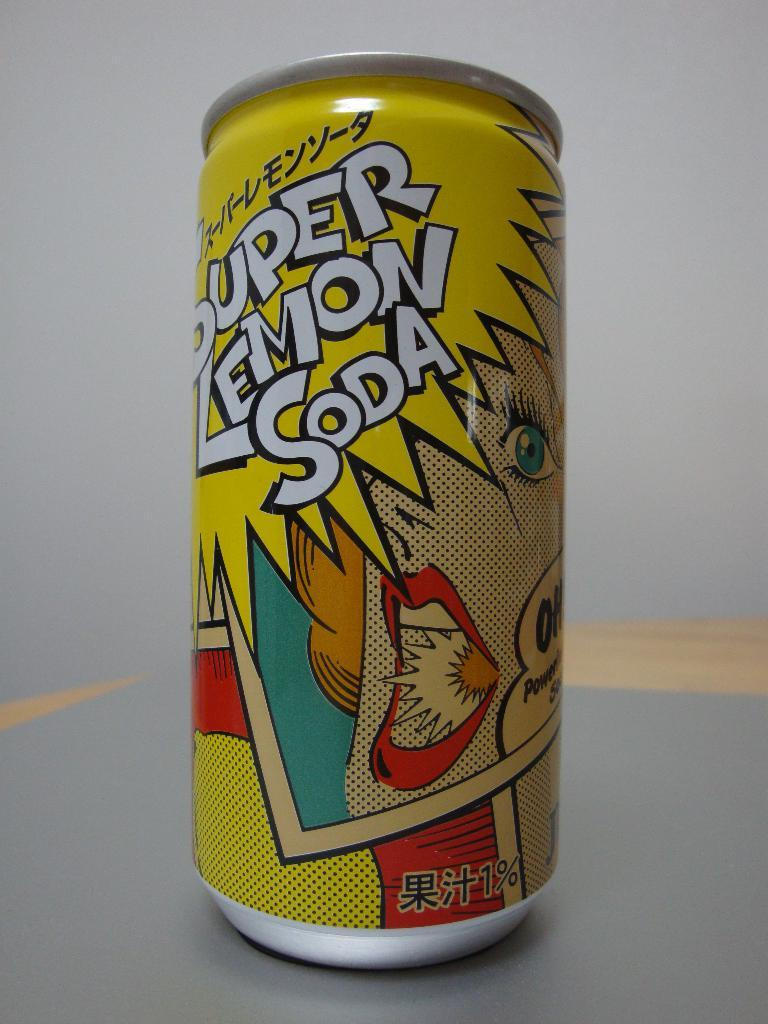<image>
Offer a succinct explanation of the picture presented. a can that has super lemon soda written on it 